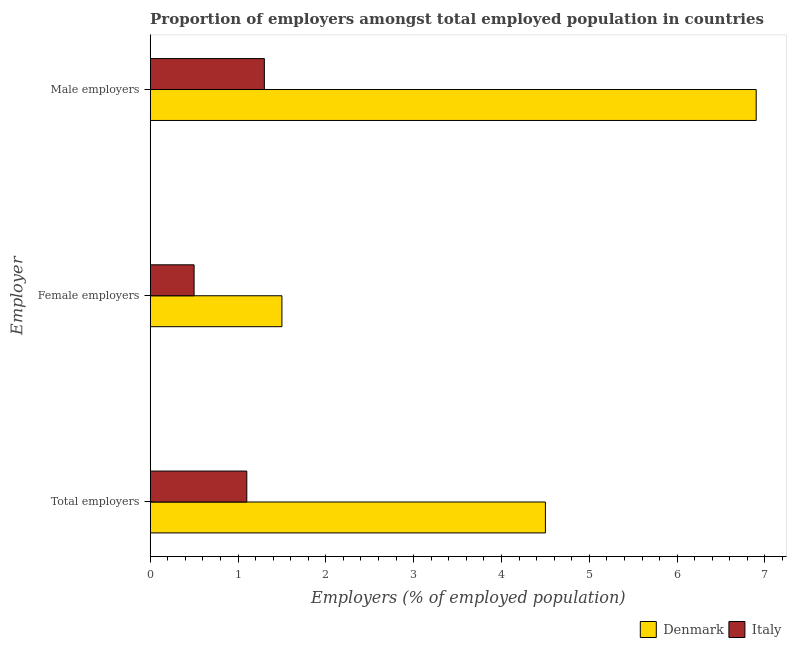How many groups of bars are there?
Offer a terse response. 3. Are the number of bars per tick equal to the number of legend labels?
Offer a very short reply. Yes. How many bars are there on the 1st tick from the top?
Ensure brevity in your answer.  2. What is the label of the 1st group of bars from the top?
Give a very brief answer. Male employers. What is the percentage of female employers in Italy?
Make the answer very short. 0.5. In which country was the percentage of female employers maximum?
Offer a very short reply. Denmark. What is the total percentage of total employers in the graph?
Give a very brief answer. 5.6. What is the difference between the percentage of total employers in Italy and that in Denmark?
Make the answer very short. -3.4. What is the difference between the percentage of male employers in Italy and the percentage of female employers in Denmark?
Your answer should be very brief. -0.2. What is the average percentage of male employers per country?
Your answer should be compact. 4.1. What is the difference between the percentage of total employers and percentage of female employers in Italy?
Give a very brief answer. 0.6. Is the difference between the percentage of male employers in Denmark and Italy greater than the difference between the percentage of total employers in Denmark and Italy?
Offer a terse response. Yes. What is the difference between the highest and the second highest percentage of male employers?
Make the answer very short. 5.6. What is the difference between the highest and the lowest percentage of male employers?
Provide a succinct answer. 5.6. In how many countries, is the percentage of male employers greater than the average percentage of male employers taken over all countries?
Ensure brevity in your answer.  1. Is the sum of the percentage of female employers in Italy and Denmark greater than the maximum percentage of male employers across all countries?
Make the answer very short. No. What does the 2nd bar from the top in Female employers represents?
Your response must be concise. Denmark. What does the 2nd bar from the bottom in Female employers represents?
Keep it short and to the point. Italy. How many countries are there in the graph?
Your answer should be compact. 2. Does the graph contain grids?
Offer a very short reply. No. How many legend labels are there?
Offer a very short reply. 2. What is the title of the graph?
Provide a short and direct response. Proportion of employers amongst total employed population in countries. Does "Spain" appear as one of the legend labels in the graph?
Your response must be concise. No. What is the label or title of the X-axis?
Give a very brief answer. Employers (% of employed population). What is the label or title of the Y-axis?
Ensure brevity in your answer.  Employer. What is the Employers (% of employed population) of Italy in Total employers?
Ensure brevity in your answer.  1.1. What is the Employers (% of employed population) in Denmark in Female employers?
Provide a succinct answer. 1.5. What is the Employers (% of employed population) in Denmark in Male employers?
Make the answer very short. 6.9. What is the Employers (% of employed population) of Italy in Male employers?
Ensure brevity in your answer.  1.3. Across all Employer, what is the maximum Employers (% of employed population) in Denmark?
Provide a short and direct response. 6.9. Across all Employer, what is the maximum Employers (% of employed population) in Italy?
Make the answer very short. 1.3. Across all Employer, what is the minimum Employers (% of employed population) in Denmark?
Keep it short and to the point. 1.5. What is the difference between the Employers (% of employed population) of Denmark in Total employers and that in Female employers?
Offer a terse response. 3. What is the difference between the Employers (% of employed population) of Italy in Total employers and that in Female employers?
Your response must be concise. 0.6. What is the difference between the Employers (% of employed population) in Denmark in Total employers and that in Male employers?
Keep it short and to the point. -2.4. What is the difference between the Employers (% of employed population) in Italy in Total employers and that in Male employers?
Offer a terse response. -0.2. What is the difference between the Employers (% of employed population) of Denmark in Female employers and that in Male employers?
Ensure brevity in your answer.  -5.4. What is the difference between the Employers (% of employed population) in Denmark in Total employers and the Employers (% of employed population) in Italy in Female employers?
Make the answer very short. 4. What is the average Employers (% of employed population) of Denmark per Employer?
Ensure brevity in your answer.  4.3. What is the average Employers (% of employed population) in Italy per Employer?
Make the answer very short. 0.97. What is the difference between the Employers (% of employed population) of Denmark and Employers (% of employed population) of Italy in Total employers?
Offer a terse response. 3.4. What is the difference between the Employers (% of employed population) in Denmark and Employers (% of employed population) in Italy in Female employers?
Keep it short and to the point. 1. What is the ratio of the Employers (% of employed population) in Italy in Total employers to that in Female employers?
Your answer should be compact. 2.2. What is the ratio of the Employers (% of employed population) in Denmark in Total employers to that in Male employers?
Provide a succinct answer. 0.65. What is the ratio of the Employers (% of employed population) of Italy in Total employers to that in Male employers?
Offer a terse response. 0.85. What is the ratio of the Employers (% of employed population) of Denmark in Female employers to that in Male employers?
Ensure brevity in your answer.  0.22. What is the ratio of the Employers (% of employed population) of Italy in Female employers to that in Male employers?
Make the answer very short. 0.38. What is the difference between the highest and the lowest Employers (% of employed population) in Italy?
Give a very brief answer. 0.8. 